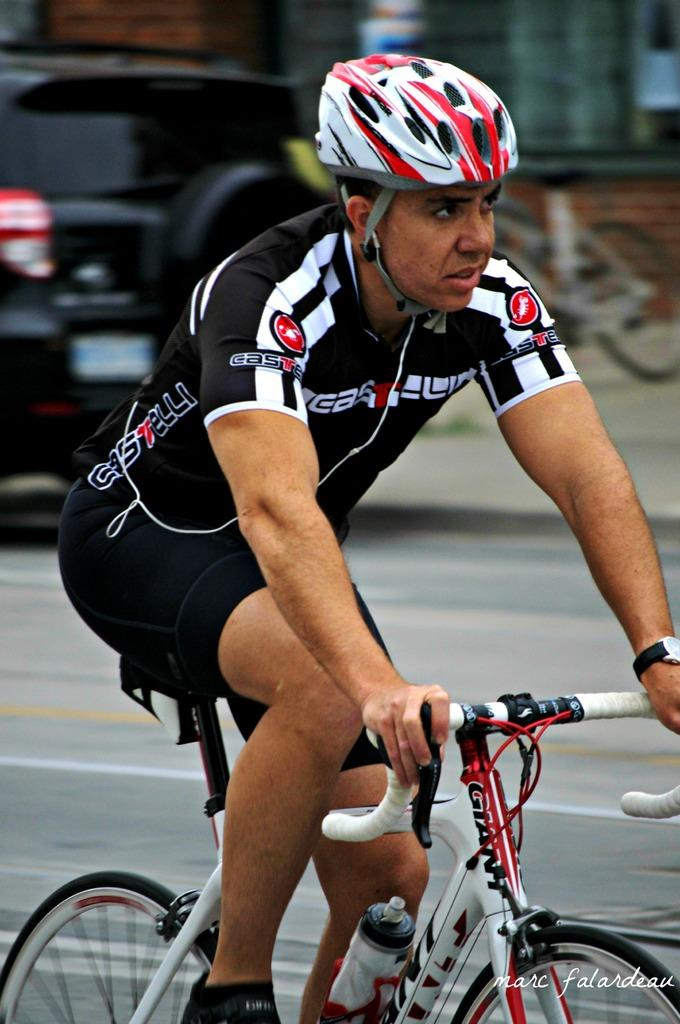Who is in the image? There is a person in the image. What is the person wearing? The person is wearing a black dress. What mode of transportation is the person using? The person is riding a white bicycle. Where is the person located? The person is on the road. What is behind the person? There is a black car behind the person. Reasoning: Let' Let's think step by step in order to produce the conversation. We start by identifying the main subject in the image, which is the person. Then, we describe the person's clothing and mode of transportation. Next, we mention the location of the person, which is on the road. Finally, we describe the object behind the person, which is a black car. Each question is designed to elicit a specific detail about the image that is known from the provided facts. Absurd Question/Answer: How many minutes does it take for the person to ride the bicycle in the image? The image does not provide information about the duration of the person's ride, so we cannot determine how many minutes it takes for the person to ride the bicycle. 